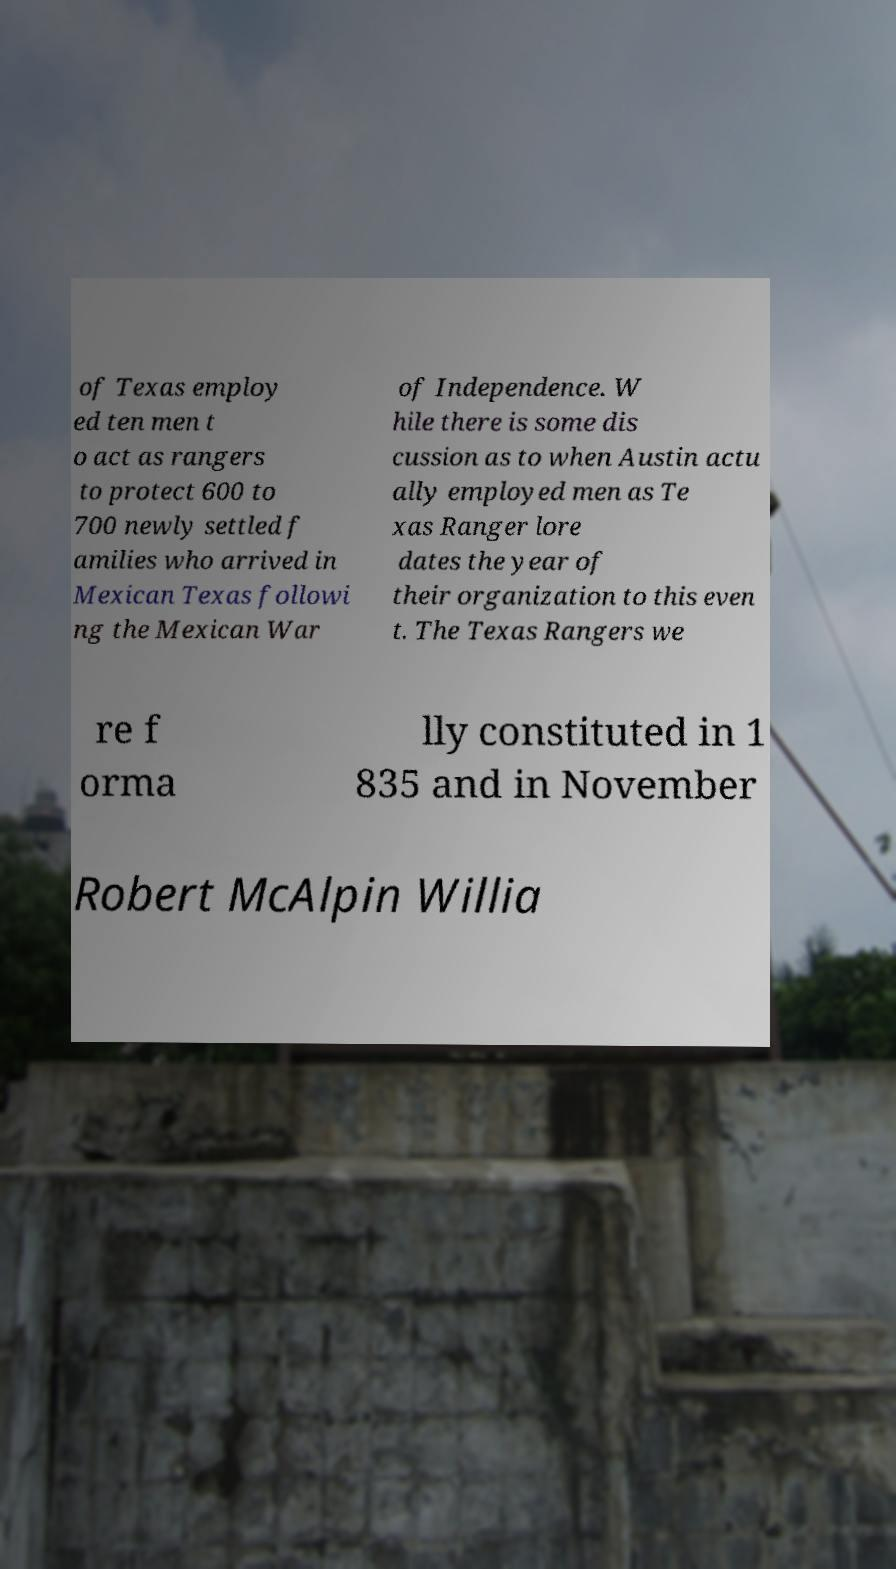Could you assist in decoding the text presented in this image and type it out clearly? of Texas employ ed ten men t o act as rangers to protect 600 to 700 newly settled f amilies who arrived in Mexican Texas followi ng the Mexican War of Independence. W hile there is some dis cussion as to when Austin actu ally employed men as Te xas Ranger lore dates the year of their organization to this even t. The Texas Rangers we re f orma lly constituted in 1 835 and in November Robert McAlpin Willia 